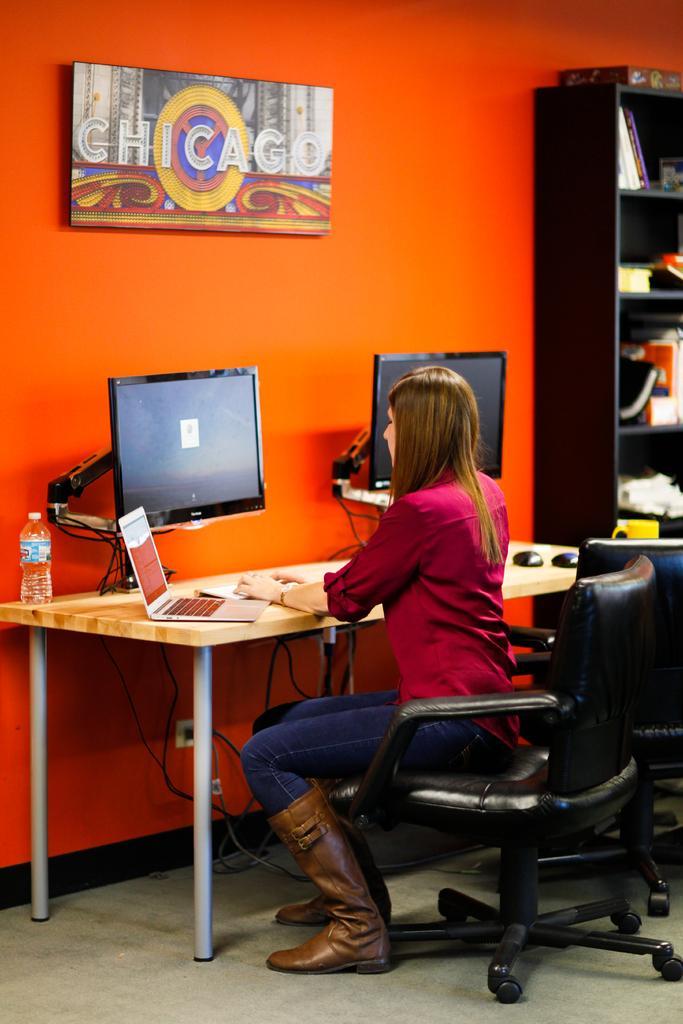Please provide a concise description of this image. As we can see in the image there is a orange color wall, photo frame, rack filled with books, a woman sitting on chair and a table. On table there is a laptop, two screens, water bottle and two mouses. 